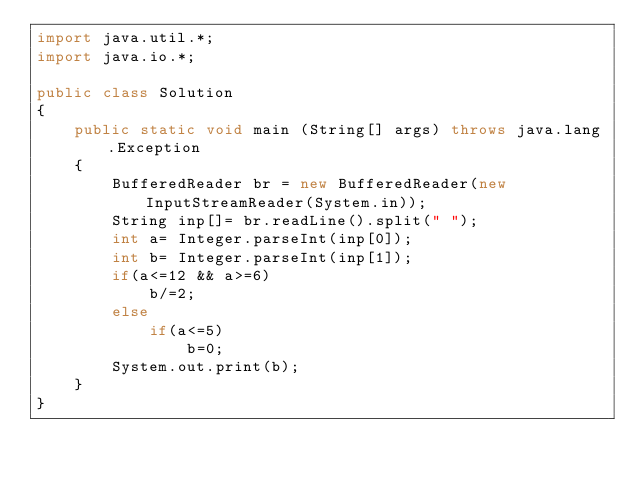Convert code to text. <code><loc_0><loc_0><loc_500><loc_500><_Java_>import java.util.*;
import java.io.*;

public class Solution
{
	public static void main (String[] args) throws java.lang.Exception
	{
		BufferedReader br = new BufferedReader(new InputStreamReader(System.in));
		String inp[]= br.readLine().split(" ");
        int a= Integer.parseInt(inp[0]);
        int b= Integer.parseInt(inp[1]);
        if(a<=12 && a>=6)
        	b/=2;
        else
        	if(a<=5)
        		b=0;
        System.out.print(b);
	}
}</code> 